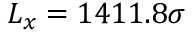<formula> <loc_0><loc_0><loc_500><loc_500>L _ { x } = 1 4 1 1 . 8 \sigma</formula> 